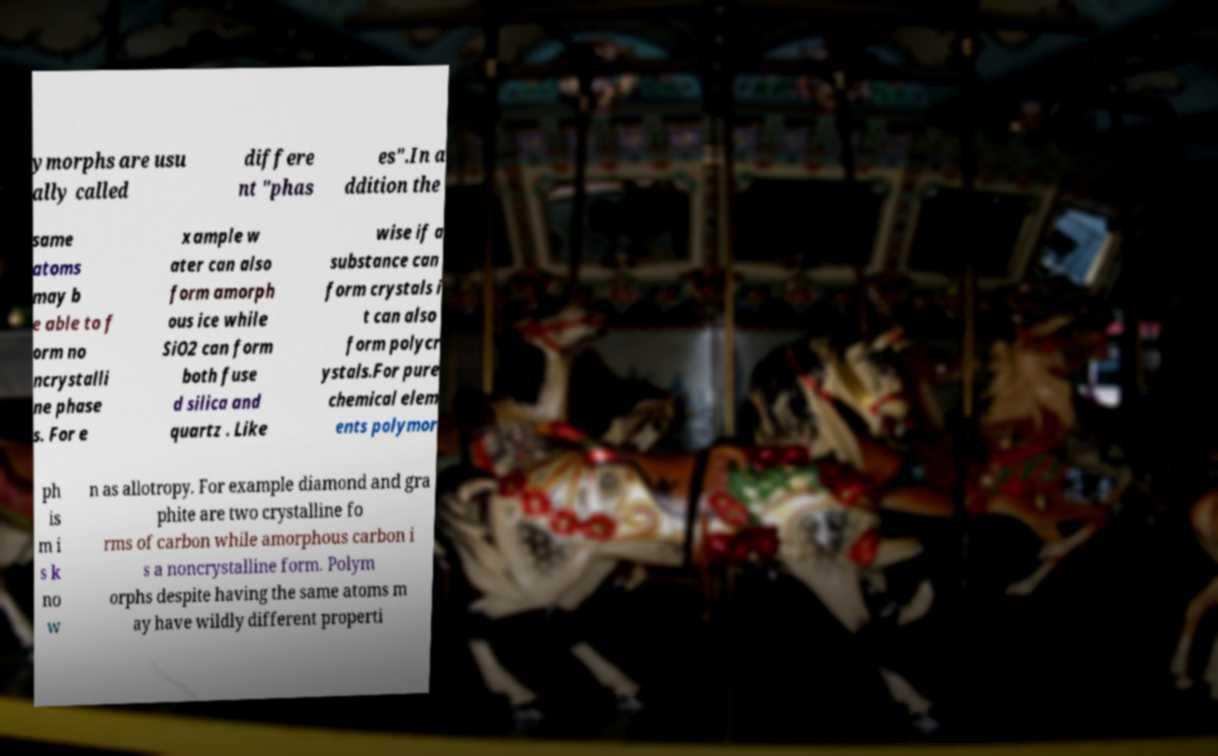Please read and relay the text visible in this image. What does it say? ymorphs are usu ally called differe nt "phas es".In a ddition the same atoms may b e able to f orm no ncrystalli ne phase s. For e xample w ater can also form amorph ous ice while SiO2 can form both fuse d silica and quartz . Like wise if a substance can form crystals i t can also form polycr ystals.For pure chemical elem ents polymor ph is m i s k no w n as allotropy. For example diamond and gra phite are two crystalline fo rms of carbon while amorphous carbon i s a noncrystalline form. Polym orphs despite having the same atoms m ay have wildly different properti 